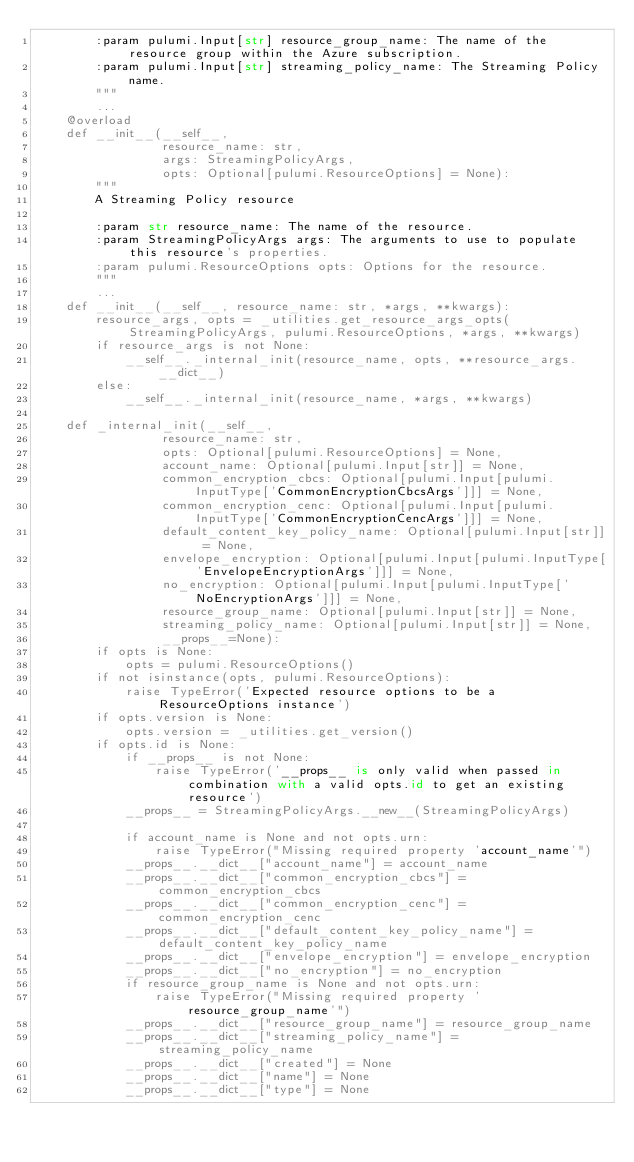<code> <loc_0><loc_0><loc_500><loc_500><_Python_>        :param pulumi.Input[str] resource_group_name: The name of the resource group within the Azure subscription.
        :param pulumi.Input[str] streaming_policy_name: The Streaming Policy name.
        """
        ...
    @overload
    def __init__(__self__,
                 resource_name: str,
                 args: StreamingPolicyArgs,
                 opts: Optional[pulumi.ResourceOptions] = None):
        """
        A Streaming Policy resource

        :param str resource_name: The name of the resource.
        :param StreamingPolicyArgs args: The arguments to use to populate this resource's properties.
        :param pulumi.ResourceOptions opts: Options for the resource.
        """
        ...
    def __init__(__self__, resource_name: str, *args, **kwargs):
        resource_args, opts = _utilities.get_resource_args_opts(StreamingPolicyArgs, pulumi.ResourceOptions, *args, **kwargs)
        if resource_args is not None:
            __self__._internal_init(resource_name, opts, **resource_args.__dict__)
        else:
            __self__._internal_init(resource_name, *args, **kwargs)

    def _internal_init(__self__,
                 resource_name: str,
                 opts: Optional[pulumi.ResourceOptions] = None,
                 account_name: Optional[pulumi.Input[str]] = None,
                 common_encryption_cbcs: Optional[pulumi.Input[pulumi.InputType['CommonEncryptionCbcsArgs']]] = None,
                 common_encryption_cenc: Optional[pulumi.Input[pulumi.InputType['CommonEncryptionCencArgs']]] = None,
                 default_content_key_policy_name: Optional[pulumi.Input[str]] = None,
                 envelope_encryption: Optional[pulumi.Input[pulumi.InputType['EnvelopeEncryptionArgs']]] = None,
                 no_encryption: Optional[pulumi.Input[pulumi.InputType['NoEncryptionArgs']]] = None,
                 resource_group_name: Optional[pulumi.Input[str]] = None,
                 streaming_policy_name: Optional[pulumi.Input[str]] = None,
                 __props__=None):
        if opts is None:
            opts = pulumi.ResourceOptions()
        if not isinstance(opts, pulumi.ResourceOptions):
            raise TypeError('Expected resource options to be a ResourceOptions instance')
        if opts.version is None:
            opts.version = _utilities.get_version()
        if opts.id is None:
            if __props__ is not None:
                raise TypeError('__props__ is only valid when passed in combination with a valid opts.id to get an existing resource')
            __props__ = StreamingPolicyArgs.__new__(StreamingPolicyArgs)

            if account_name is None and not opts.urn:
                raise TypeError("Missing required property 'account_name'")
            __props__.__dict__["account_name"] = account_name
            __props__.__dict__["common_encryption_cbcs"] = common_encryption_cbcs
            __props__.__dict__["common_encryption_cenc"] = common_encryption_cenc
            __props__.__dict__["default_content_key_policy_name"] = default_content_key_policy_name
            __props__.__dict__["envelope_encryption"] = envelope_encryption
            __props__.__dict__["no_encryption"] = no_encryption
            if resource_group_name is None and not opts.urn:
                raise TypeError("Missing required property 'resource_group_name'")
            __props__.__dict__["resource_group_name"] = resource_group_name
            __props__.__dict__["streaming_policy_name"] = streaming_policy_name
            __props__.__dict__["created"] = None
            __props__.__dict__["name"] = None
            __props__.__dict__["type"] = None</code> 